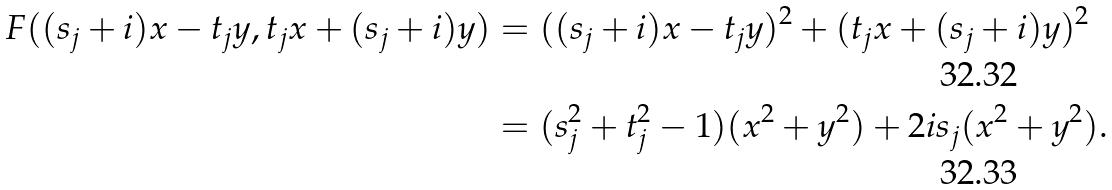<formula> <loc_0><loc_0><loc_500><loc_500>F ( ( s _ { j } + i ) x - t _ { j } y , t _ { j } x + ( s _ { j } + i ) y ) & = ( ( s _ { j } + i ) x - t _ { j } y ) ^ { 2 } + ( t _ { j } x + ( s _ { j } + i ) y ) ^ { 2 } \\ & = ( s _ { j } ^ { 2 } + t _ { j } ^ { 2 } - 1 ) ( x ^ { 2 } + y ^ { 2 } ) + 2 i s _ { j } ( x ^ { 2 } + y ^ { 2 } ) .</formula> 